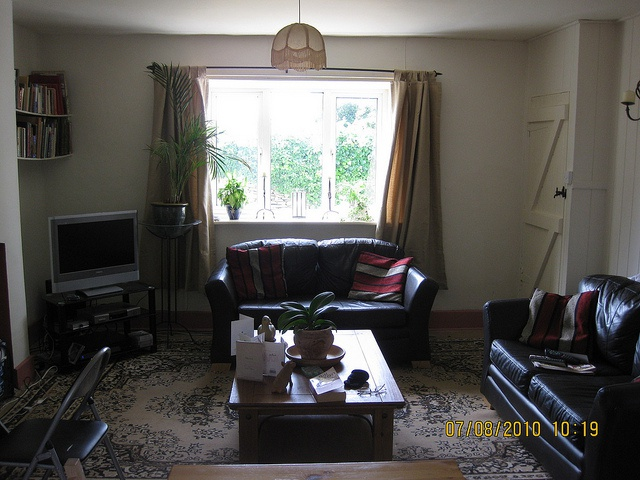Describe the objects in this image and their specific colors. I can see couch in gray, black, and navy tones, chair in gray, black, and navy tones, couch in gray, black, lavender, and maroon tones, potted plant in gray, black, darkgreen, and white tones, and chair in gray and black tones in this image. 